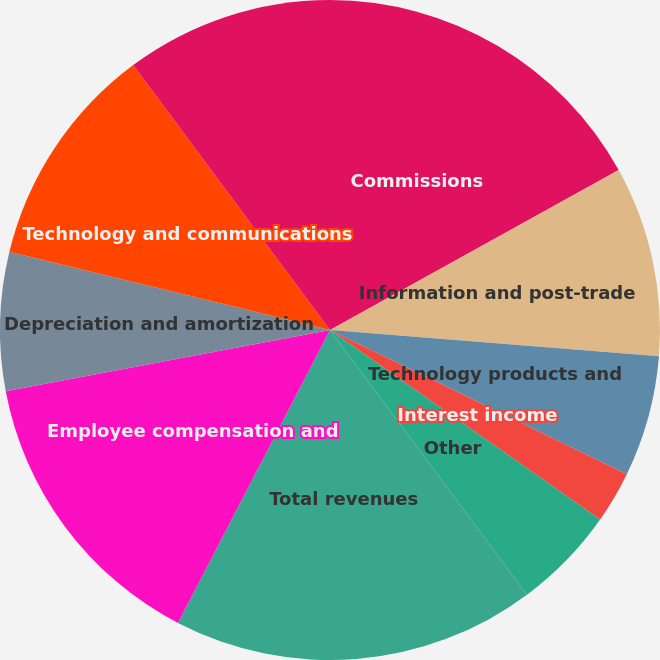Convert chart. <chart><loc_0><loc_0><loc_500><loc_500><pie_chart><fcel>Commissions<fcel>Information and post-trade<fcel>Technology products and<fcel>Interest income<fcel>Other<fcel>Total revenues<fcel>Employee compensation and<fcel>Depreciation and amortization<fcel>Technology and communications<fcel>Professional and consulting<nl><fcel>16.95%<fcel>9.32%<fcel>5.93%<fcel>2.54%<fcel>5.08%<fcel>17.8%<fcel>14.41%<fcel>6.78%<fcel>11.02%<fcel>10.17%<nl></chart> 